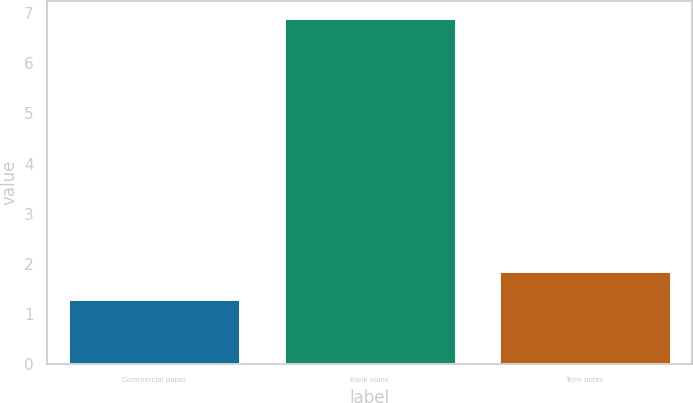Convert chart. <chart><loc_0><loc_0><loc_500><loc_500><bar_chart><fcel>Commercial paper<fcel>Bank loans<fcel>Term notes<nl><fcel>1.3<fcel>6.9<fcel>1.86<nl></chart> 